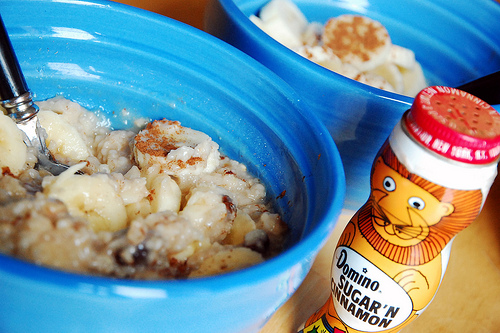<image>
Can you confirm if the bowl is under the food? Yes. The bowl is positioned underneath the food, with the food above it in the vertical space. 